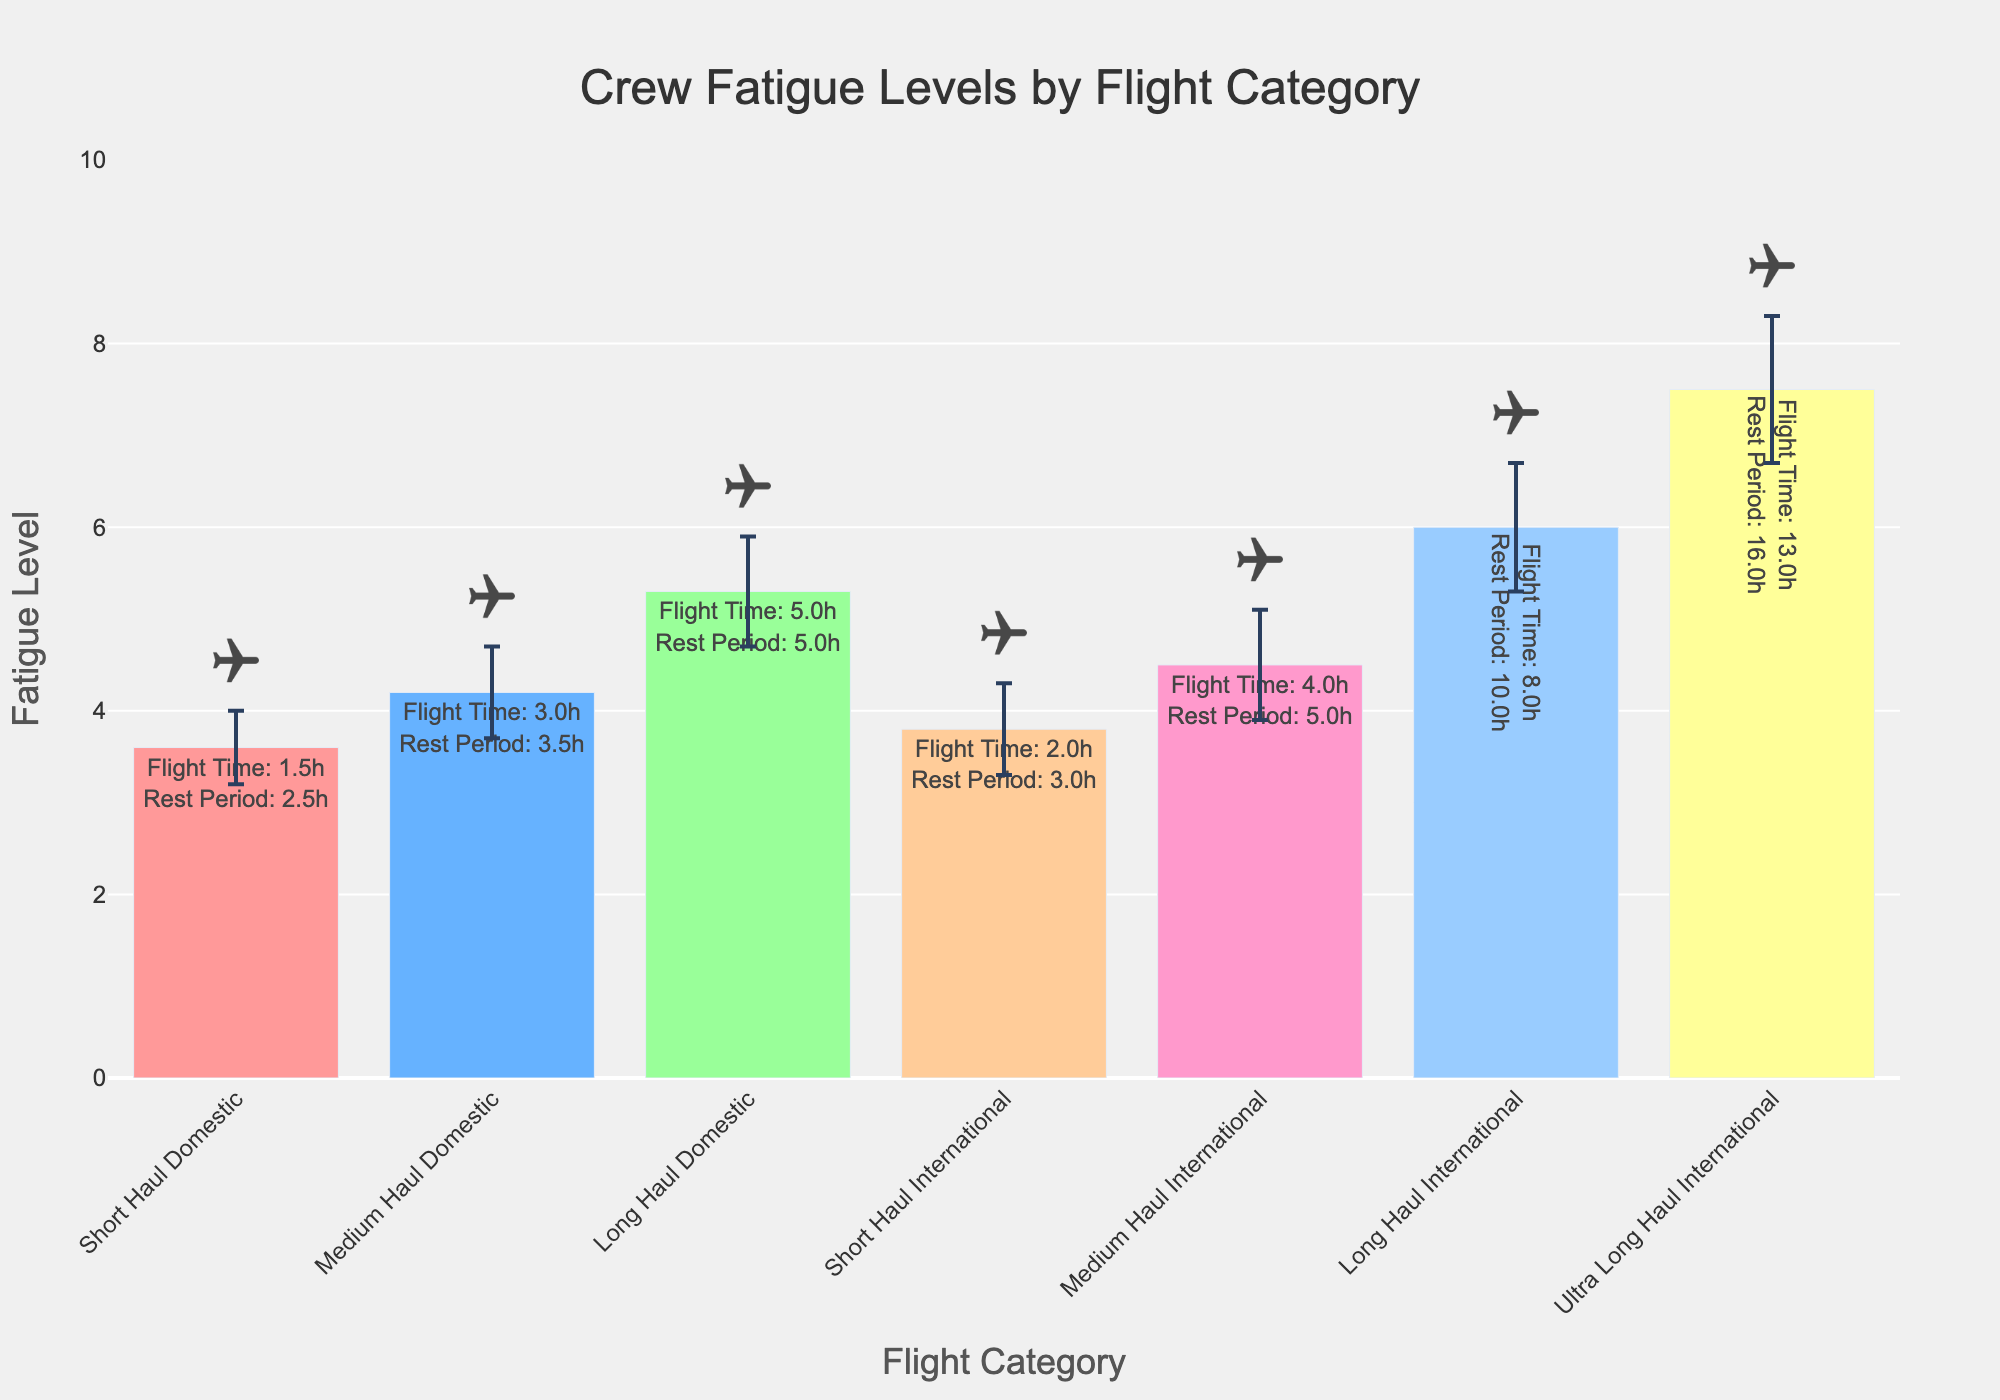What is the title of the figure? The title is displayed at the top center of the figure and clearly states the overall topic.
Answer: Crew Fatigue Levels by Flight Category What is the range of the y-axis? The y-axis range starts from 0 and goes up to 10, as indicated on the axis itself.
Answer: 0 to 10 Which flight category has the highest average fatigue level? The category with the highest bar represents the highest average fatigue level, which is "Ultra Long Haul International" with a mean of 7.5.
Answer: Ultra Long Haul International What is the average fatigue level for Short Haul Domestic flights? The bar for "Short Haul Domestic" shows a mean fatigue level of 3.6, which can be directly read from the figure.
Answer: 3.6 Among the categories, which one has the smallest error bar? The size of the error bar represents the standard deviation. The category with the smallest error bar is "Short Haul Domestic" with a standard deviation of 0.4.
Answer: Short Haul Domestic How does the fatigue level change from Medium Haul Domestic to Medium Haul International? To answer this, look at the heights of the Medium Haul Domestic and Medium Haul International bars. The fatigue level increases from 4.2 to 4.5.
Answer: Increases by 0.3 Compare the average flight times between Long Haul Domestic and Long Haul International. According to the hover text, Long Haul Domestic has an average flight time of 5 hours, while Long Haul International has 8 hours.
Answer: Long Haul International is 3 hours longer In which category does the average rest period significantly outpace the average flight time the most? Find the category with the largest difference between average rest period and average flight time. Ultra Long Haul International has the largest difference: 16 hours rest vs 13 hours flight.
Answer: Ultra Long Haul International Why might the error bars be larger for longer flights? Longer flights typically involve more variability in fatigue factors, hence larger error bars. Larger error bars indicate greater variability in the measured fatigue levels.
Answer: Greater variability in longer flights Which category has a fatigue level closest to 5? Identify the bar closest to 5 on the y-axis. Long Haul Domestic has a mean fatigue level of 5.3, which is closest to 5.
Answer: Long Haul Domestic 